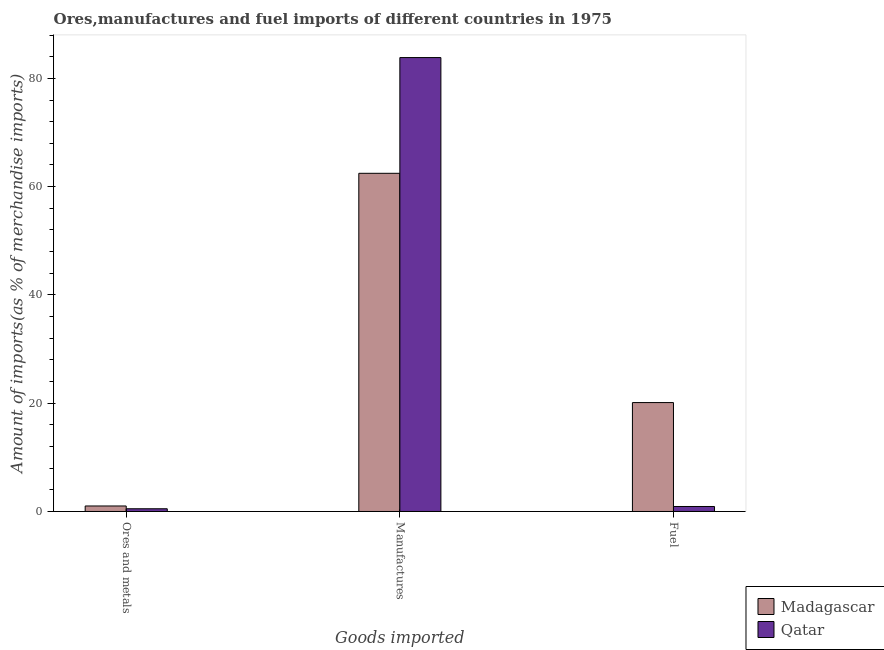How many groups of bars are there?
Provide a short and direct response. 3. Are the number of bars per tick equal to the number of legend labels?
Offer a terse response. Yes. What is the label of the 1st group of bars from the left?
Offer a terse response. Ores and metals. What is the percentage of fuel imports in Madagascar?
Your answer should be very brief. 20.12. Across all countries, what is the maximum percentage of fuel imports?
Your answer should be compact. 20.12. Across all countries, what is the minimum percentage of manufactures imports?
Offer a very short reply. 62.47. In which country was the percentage of manufactures imports maximum?
Give a very brief answer. Qatar. In which country was the percentage of manufactures imports minimum?
Keep it short and to the point. Madagascar. What is the total percentage of ores and metals imports in the graph?
Provide a short and direct response. 1.52. What is the difference between the percentage of manufactures imports in Qatar and that in Madagascar?
Make the answer very short. 21.38. What is the difference between the percentage of manufactures imports in Madagascar and the percentage of ores and metals imports in Qatar?
Ensure brevity in your answer.  61.96. What is the average percentage of manufactures imports per country?
Make the answer very short. 73.15. What is the difference between the percentage of ores and metals imports and percentage of manufactures imports in Qatar?
Give a very brief answer. -83.34. What is the ratio of the percentage of manufactures imports in Madagascar to that in Qatar?
Offer a terse response. 0.75. Is the percentage of ores and metals imports in Qatar less than that in Madagascar?
Make the answer very short. Yes. Is the difference between the percentage of ores and metals imports in Qatar and Madagascar greater than the difference between the percentage of fuel imports in Qatar and Madagascar?
Offer a very short reply. Yes. What is the difference between the highest and the second highest percentage of ores and metals imports?
Provide a short and direct response. 0.51. What is the difference between the highest and the lowest percentage of manufactures imports?
Provide a short and direct response. 21.38. What does the 1st bar from the left in Fuel represents?
Your answer should be very brief. Madagascar. What does the 1st bar from the right in Fuel represents?
Your answer should be compact. Qatar. What is the difference between two consecutive major ticks on the Y-axis?
Keep it short and to the point. 20. Are the values on the major ticks of Y-axis written in scientific E-notation?
Give a very brief answer. No. Does the graph contain grids?
Give a very brief answer. No. Where does the legend appear in the graph?
Provide a succinct answer. Bottom right. How are the legend labels stacked?
Give a very brief answer. Vertical. What is the title of the graph?
Offer a very short reply. Ores,manufactures and fuel imports of different countries in 1975. Does "Saudi Arabia" appear as one of the legend labels in the graph?
Your answer should be compact. No. What is the label or title of the X-axis?
Give a very brief answer. Goods imported. What is the label or title of the Y-axis?
Make the answer very short. Amount of imports(as % of merchandise imports). What is the Amount of imports(as % of merchandise imports) in Madagascar in Ores and metals?
Your response must be concise. 1.02. What is the Amount of imports(as % of merchandise imports) of Qatar in Ores and metals?
Your answer should be compact. 0.5. What is the Amount of imports(as % of merchandise imports) in Madagascar in Manufactures?
Your answer should be very brief. 62.47. What is the Amount of imports(as % of merchandise imports) in Qatar in Manufactures?
Give a very brief answer. 83.84. What is the Amount of imports(as % of merchandise imports) in Madagascar in Fuel?
Offer a terse response. 20.12. What is the Amount of imports(as % of merchandise imports) of Qatar in Fuel?
Provide a succinct answer. 0.92. Across all Goods imported, what is the maximum Amount of imports(as % of merchandise imports) in Madagascar?
Offer a terse response. 62.47. Across all Goods imported, what is the maximum Amount of imports(as % of merchandise imports) in Qatar?
Provide a short and direct response. 83.84. Across all Goods imported, what is the minimum Amount of imports(as % of merchandise imports) of Madagascar?
Provide a short and direct response. 1.02. Across all Goods imported, what is the minimum Amount of imports(as % of merchandise imports) of Qatar?
Make the answer very short. 0.5. What is the total Amount of imports(as % of merchandise imports) of Madagascar in the graph?
Offer a very short reply. 83.6. What is the total Amount of imports(as % of merchandise imports) of Qatar in the graph?
Provide a short and direct response. 85.27. What is the difference between the Amount of imports(as % of merchandise imports) of Madagascar in Ores and metals and that in Manufactures?
Offer a very short reply. -61.45. What is the difference between the Amount of imports(as % of merchandise imports) in Qatar in Ores and metals and that in Manufactures?
Your answer should be very brief. -83.34. What is the difference between the Amount of imports(as % of merchandise imports) of Madagascar in Ores and metals and that in Fuel?
Ensure brevity in your answer.  -19.1. What is the difference between the Amount of imports(as % of merchandise imports) in Qatar in Ores and metals and that in Fuel?
Your answer should be very brief. -0.42. What is the difference between the Amount of imports(as % of merchandise imports) in Madagascar in Manufactures and that in Fuel?
Offer a terse response. 42.35. What is the difference between the Amount of imports(as % of merchandise imports) of Qatar in Manufactures and that in Fuel?
Your answer should be compact. 82.92. What is the difference between the Amount of imports(as % of merchandise imports) in Madagascar in Ores and metals and the Amount of imports(as % of merchandise imports) in Qatar in Manufactures?
Your answer should be compact. -82.82. What is the difference between the Amount of imports(as % of merchandise imports) in Madagascar in Ores and metals and the Amount of imports(as % of merchandise imports) in Qatar in Fuel?
Keep it short and to the point. 0.09. What is the difference between the Amount of imports(as % of merchandise imports) in Madagascar in Manufactures and the Amount of imports(as % of merchandise imports) in Qatar in Fuel?
Provide a succinct answer. 61.54. What is the average Amount of imports(as % of merchandise imports) of Madagascar per Goods imported?
Your answer should be compact. 27.87. What is the average Amount of imports(as % of merchandise imports) of Qatar per Goods imported?
Ensure brevity in your answer.  28.42. What is the difference between the Amount of imports(as % of merchandise imports) in Madagascar and Amount of imports(as % of merchandise imports) in Qatar in Ores and metals?
Your answer should be very brief. 0.51. What is the difference between the Amount of imports(as % of merchandise imports) in Madagascar and Amount of imports(as % of merchandise imports) in Qatar in Manufactures?
Your response must be concise. -21.38. What is the difference between the Amount of imports(as % of merchandise imports) of Madagascar and Amount of imports(as % of merchandise imports) of Qatar in Fuel?
Ensure brevity in your answer.  19.19. What is the ratio of the Amount of imports(as % of merchandise imports) of Madagascar in Ores and metals to that in Manufactures?
Your answer should be compact. 0.02. What is the ratio of the Amount of imports(as % of merchandise imports) in Qatar in Ores and metals to that in Manufactures?
Ensure brevity in your answer.  0.01. What is the ratio of the Amount of imports(as % of merchandise imports) in Madagascar in Ores and metals to that in Fuel?
Offer a terse response. 0.05. What is the ratio of the Amount of imports(as % of merchandise imports) of Qatar in Ores and metals to that in Fuel?
Your answer should be compact. 0.54. What is the ratio of the Amount of imports(as % of merchandise imports) of Madagascar in Manufactures to that in Fuel?
Give a very brief answer. 3.11. What is the ratio of the Amount of imports(as % of merchandise imports) of Qatar in Manufactures to that in Fuel?
Offer a terse response. 90.82. What is the difference between the highest and the second highest Amount of imports(as % of merchandise imports) of Madagascar?
Provide a short and direct response. 42.35. What is the difference between the highest and the second highest Amount of imports(as % of merchandise imports) of Qatar?
Your response must be concise. 82.92. What is the difference between the highest and the lowest Amount of imports(as % of merchandise imports) of Madagascar?
Ensure brevity in your answer.  61.45. What is the difference between the highest and the lowest Amount of imports(as % of merchandise imports) in Qatar?
Offer a terse response. 83.34. 